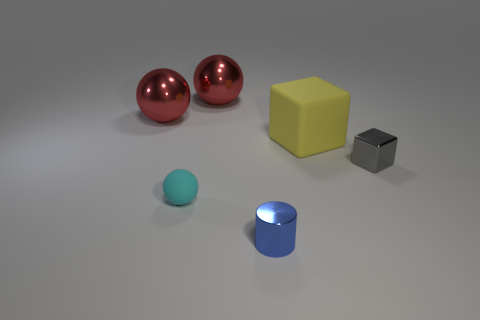Add 1 large metallic spheres. How many objects exist? 7 Subtract all blocks. How many objects are left? 4 Add 6 gray blocks. How many gray blocks are left? 7 Add 4 red spheres. How many red spheres exist? 6 Subtract 0 gray spheres. How many objects are left? 6 Subtract all blue metal objects. Subtract all yellow objects. How many objects are left? 4 